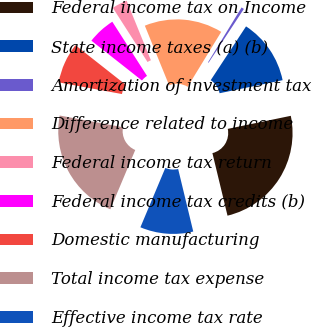<chart> <loc_0><loc_0><loc_500><loc_500><pie_chart><fcel>Federal income tax on Income<fcel>State income taxes (a) (b)<fcel>Amortization of investment tax<fcel>Difference related to income<fcel>Federal income tax return<fcel>Federal income tax credits (b)<fcel>Domestic manufacturing<fcel>Total income tax expense<fcel>Effective income tax rate<nl><fcel>24.48%<fcel>12.5%<fcel>0.52%<fcel>14.89%<fcel>2.91%<fcel>5.31%<fcel>7.71%<fcel>21.58%<fcel>10.1%<nl></chart> 